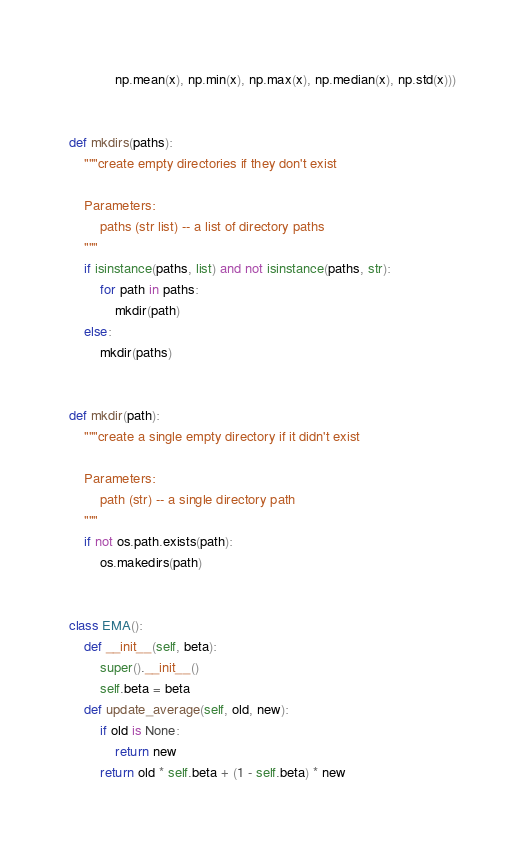<code> <loc_0><loc_0><loc_500><loc_500><_Python_>            np.mean(x), np.min(x), np.max(x), np.median(x), np.std(x)))


def mkdirs(paths):
    """create empty directories if they don't exist

    Parameters:
        paths (str list) -- a list of directory paths
    """
    if isinstance(paths, list) and not isinstance(paths, str):
        for path in paths:
            mkdir(path)
    else:
        mkdir(paths)


def mkdir(path):
    """create a single empty directory if it didn't exist

    Parameters:
        path (str) -- a single directory path
    """
    if not os.path.exists(path):
        os.makedirs(path)


class EMA():
    def __init__(self, beta):
        super().__init__()
        self.beta = beta
    def update_average(self, old, new):
        if old is None:
            return new
        return old * self.beta + (1 - self.beta) * new</code> 